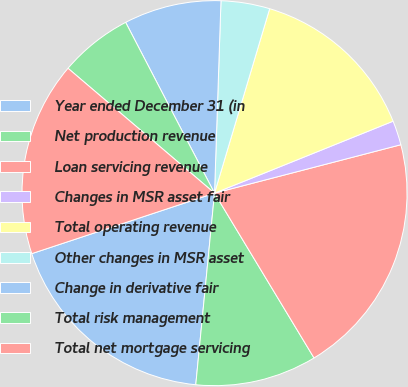Convert chart. <chart><loc_0><loc_0><loc_500><loc_500><pie_chart><fcel>Year ended December 31 (in<fcel>Net production revenue<fcel>Loan servicing revenue<fcel>Changes in MSR asset fair<fcel>Total operating revenue<fcel>Other changes in MSR asset<fcel>Change in derivative fair<fcel>Total risk management<fcel>Total net mortgage servicing<nl><fcel>18.36%<fcel>10.2%<fcel>20.4%<fcel>2.05%<fcel>14.28%<fcel>4.09%<fcel>8.17%<fcel>6.13%<fcel>16.32%<nl></chart> 